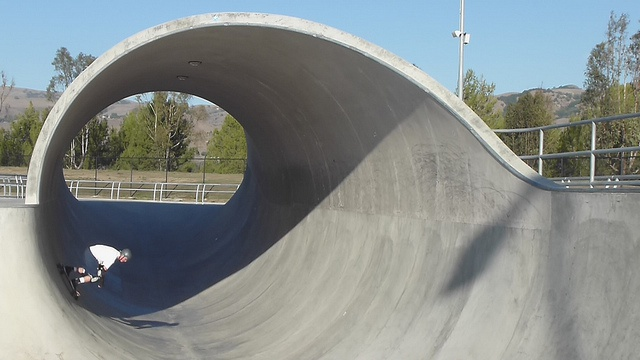Describe the objects in this image and their specific colors. I can see people in lightblue, white, gray, black, and darkblue tones and skateboard in lightblue, black, gray, and darkgray tones in this image. 